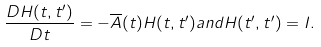<formula> <loc_0><loc_0><loc_500><loc_500>\frac { D H ( t , t ^ { \prime } ) } { D t } = - \overline { A } ( t ) H ( t , t ^ { \prime } ) a n d H ( t ^ { \prime } , t ^ { \prime } ) = { I } .</formula> 